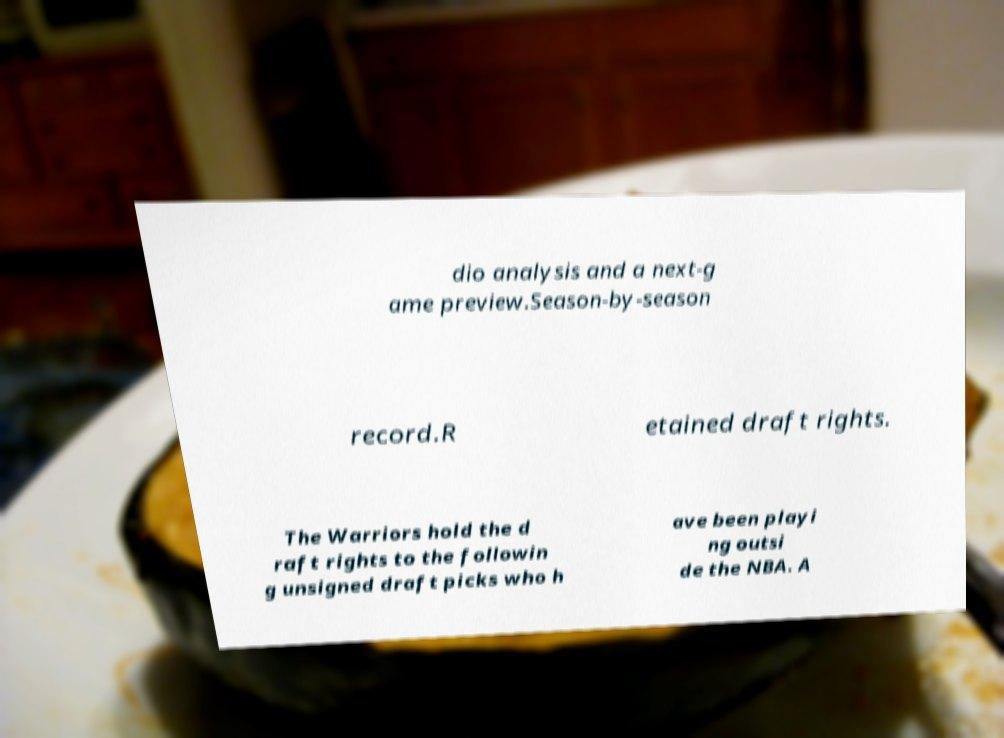Can you accurately transcribe the text from the provided image for me? dio analysis and a next-g ame preview.Season-by-season record.R etained draft rights. The Warriors hold the d raft rights to the followin g unsigned draft picks who h ave been playi ng outsi de the NBA. A 